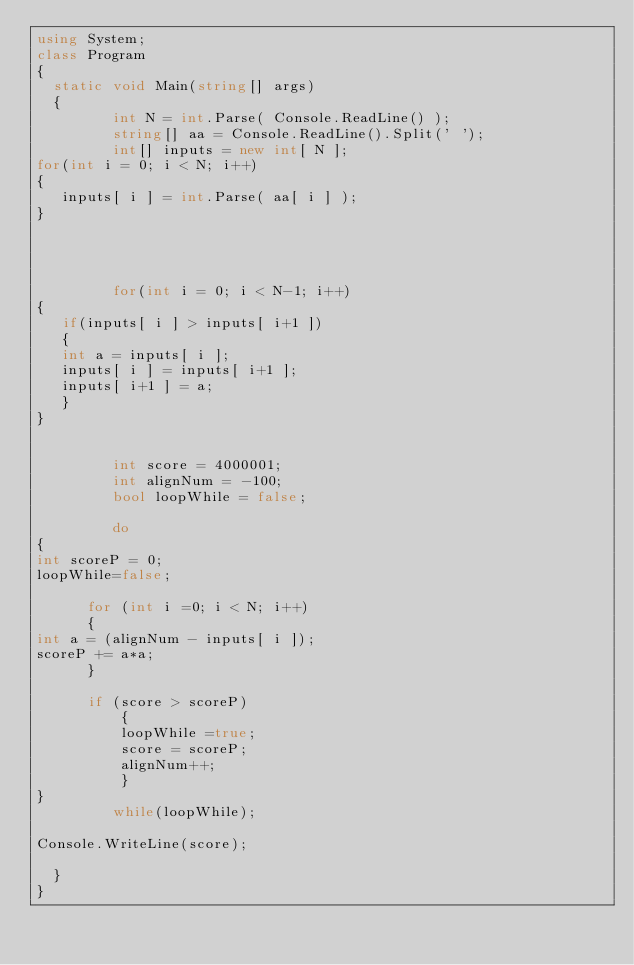Convert code to text. <code><loc_0><loc_0><loc_500><loc_500><_C#_>using System;
class Program
{
	static void Main(string[] args)
	{
         int N = int.Parse( Console.ReadLine() );
         string[] aa = Console.ReadLine().Split(' ');
         int[] inputs = new int[ N ];
for(int i = 0; i < N; i++)
{
   inputs[ i ] = int.Parse( aa[ i ] );
}




         for(int i = 0; i < N-1; i++)
{
   if(inputs[ i ] > inputs[ i+1 ])
   {
   int a = inputs[ i ];
   inputs[ i ] = inputs[ i+1 ];
   inputs[ i+1 ] = a;
   }
}

         
         int score = 4000001;
         int alignNum = -100;
         bool loopWhile = false;
         
         do
{
int scoreP = 0;
loopWhile=false;

      for (int i =0; i < N; i++)
      {
int a = (alignNum - inputs[ i ]);
scoreP += a*a; 
      }

      if (score > scoreP)
          {
          loopWhile =true;
          score = scoreP;
          alignNum++;
          }
}
         while(loopWhile);

Console.WriteLine(score);

	}
}</code> 